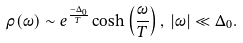<formula> <loc_0><loc_0><loc_500><loc_500>\rho ( \omega ) \sim e ^ { \frac { - \Delta _ { 0 } } { T } } \cosh \left ( \frac { \omega } { T } \right ) , \, | \omega | \ll \Delta _ { 0 } .</formula> 